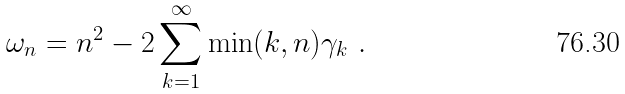<formula> <loc_0><loc_0><loc_500><loc_500>\omega _ { n } = n ^ { 2 } - 2 \sum _ { k = 1 } ^ { \infty } \min ( k , n ) \gamma _ { k } \ .</formula> 